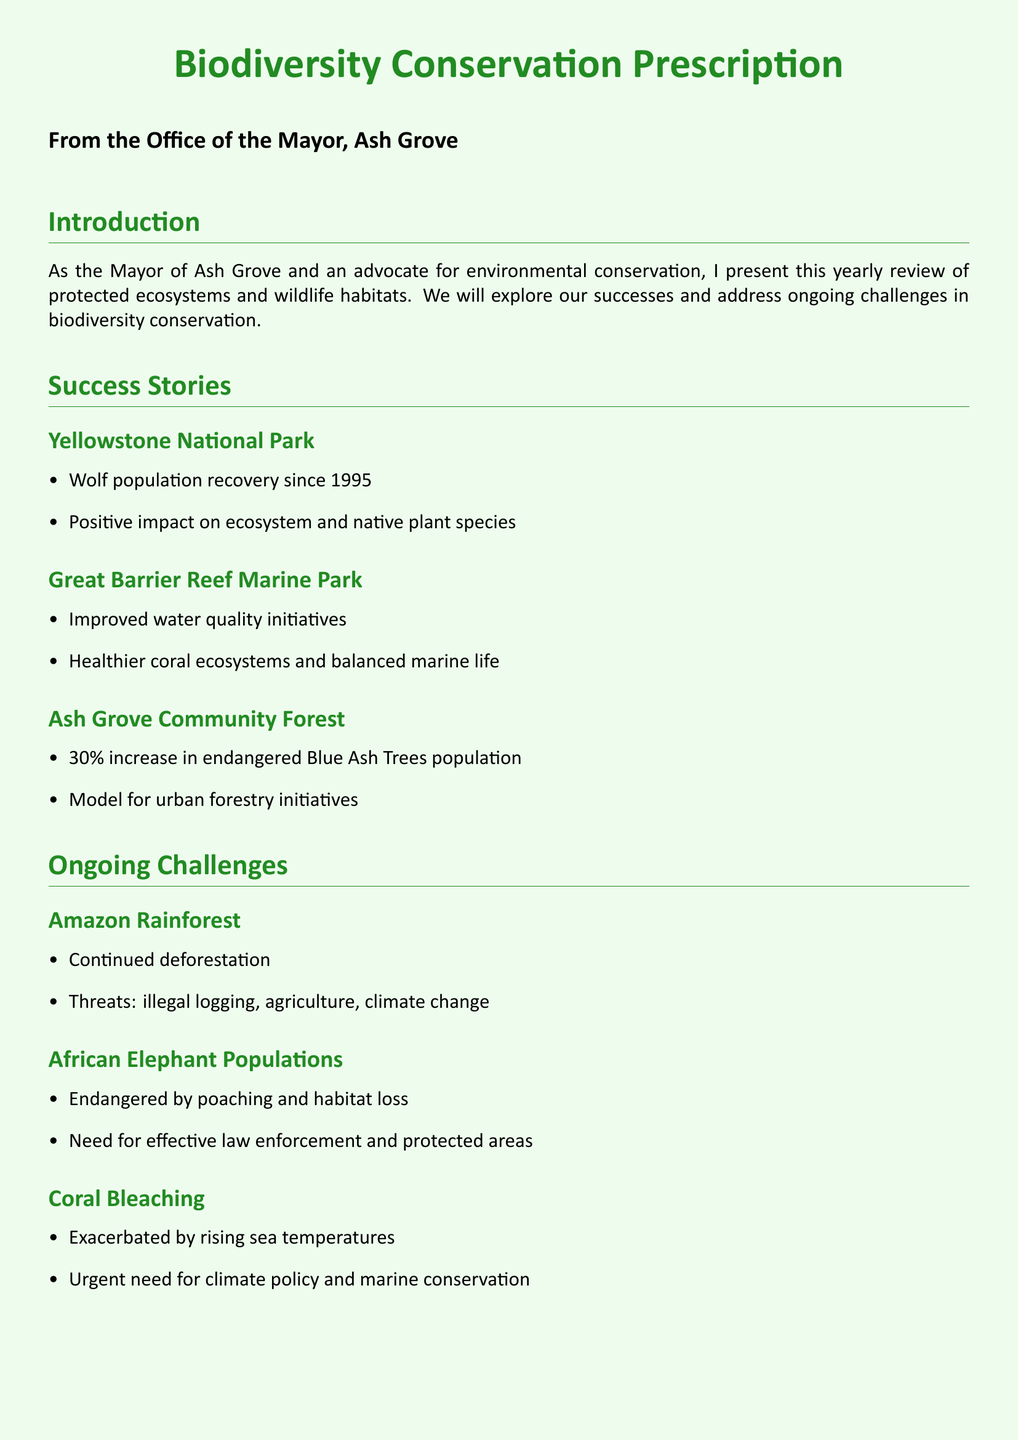What is the main focus of this document? The main focus of the document is a yearly review of protected ecosystems and wildlife habitats regarding successes and challenges in biodiversity conservation.
Answer: Biodiversity conservation What percentage increase was reported for the Blue Ash Trees in Ash Grove Community Forest? The document states that there was a 30% increase in the endangered Blue Ash Trees population.
Answer: 30% What is one major ongoing challenge facing the Amazon Rainforest? The document lists continued deforestation as a major ongoing challenge affecting the Amazon Rainforest.
Answer: Deforestation Which park achieved a recovery of the wolf population since 1995? The document mentions Yellowstone National Park as the location where wolf population recovery has occurred since 1995.
Answer: Yellowstone National Park What specific type of tree population improved by 30% in Ash Grove? The document refers to the endangered Blue Ash Trees population that improved by 30%.
Answer: Blue Ash Trees What urgent action is required to combat coral bleaching? The document emphasizes the urgent need for climate policy and marine conservation to address coral bleaching issues.
Answer: Climate policy What kind of initiatives are suggested for residents of Ash Grove? The document suggests supporting environmental initiatives as one of the actions for residents of Ash Grove.
Answer: Environmental initiatives What are two threats to African elephant populations? The document mentions poaching and habitat loss as two key threats to African elephant populations.
Answer: Poaching and habitat loss 